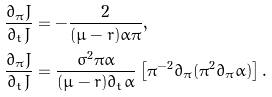Convert formula to latex. <formula><loc_0><loc_0><loc_500><loc_500>\frac { \partial _ { \pi } J } { \partial _ { t } J } & = - \frac { 2 } { ( \mu - r ) \alpha \pi } , \\ \frac { \partial _ { \pi } J } { \partial _ { t } J } & = \frac { \sigma ^ { 2 } \pi \alpha } { ( \mu - r ) \partial _ { t } \alpha } \left [ \pi ^ { - 2 } \partial _ { \pi } ( \pi ^ { 2 } \partial _ { \pi } \alpha ) \right ] .</formula> 